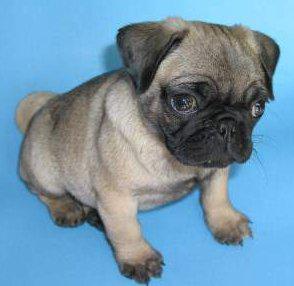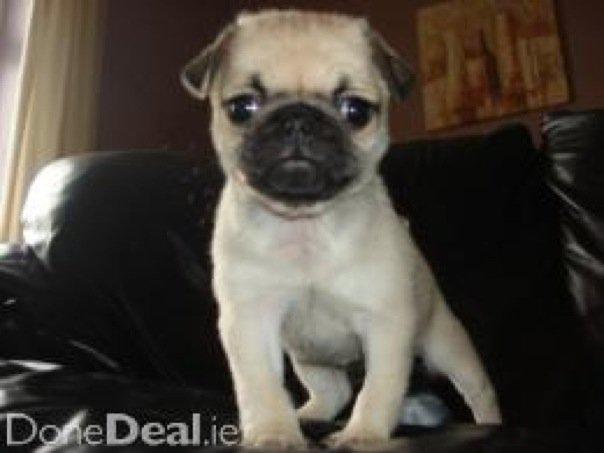The first image is the image on the left, the second image is the image on the right. Considering the images on both sides, is "An image shows just one pug dog on a leather-type seat." valid? Answer yes or no. Yes. The first image is the image on the left, the second image is the image on the right. Evaluate the accuracy of this statement regarding the images: "A dog is sitting on a shiny seat in the image on the right.". Is it true? Answer yes or no. Yes. 